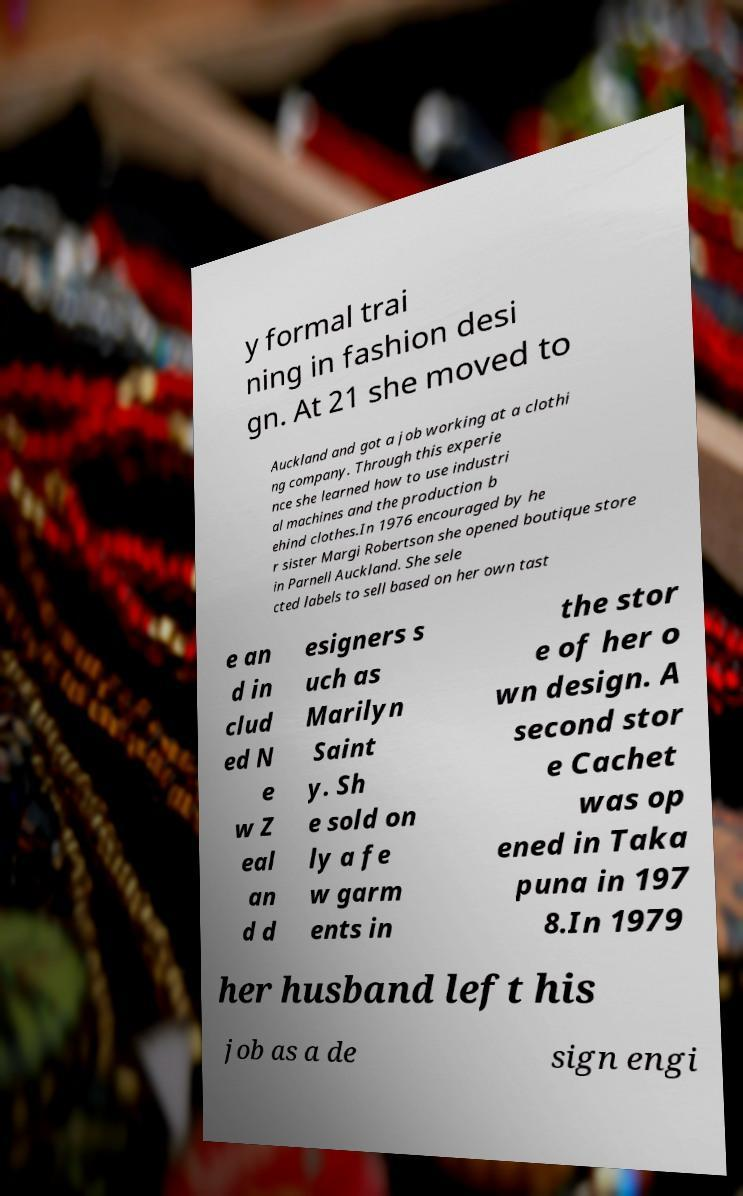I need the written content from this picture converted into text. Can you do that? y formal trai ning in fashion desi gn. At 21 she moved to Auckland and got a job working at a clothi ng company. Through this experie nce she learned how to use industri al machines and the production b ehind clothes.In 1976 encouraged by he r sister Margi Robertson she opened boutique store in Parnell Auckland. She sele cted labels to sell based on her own tast e an d in clud ed N e w Z eal an d d esigners s uch as Marilyn Saint y. Sh e sold on ly a fe w garm ents in the stor e of her o wn design. A second stor e Cachet was op ened in Taka puna in 197 8.In 1979 her husband left his job as a de sign engi 